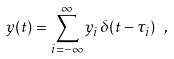Convert formula to latex. <formula><loc_0><loc_0><loc_500><loc_500>y ( t ) = \sum _ { i = - \infty } ^ { \infty } y _ { i } \, \delta ( t - \tau _ { i } ) \ ,</formula> 